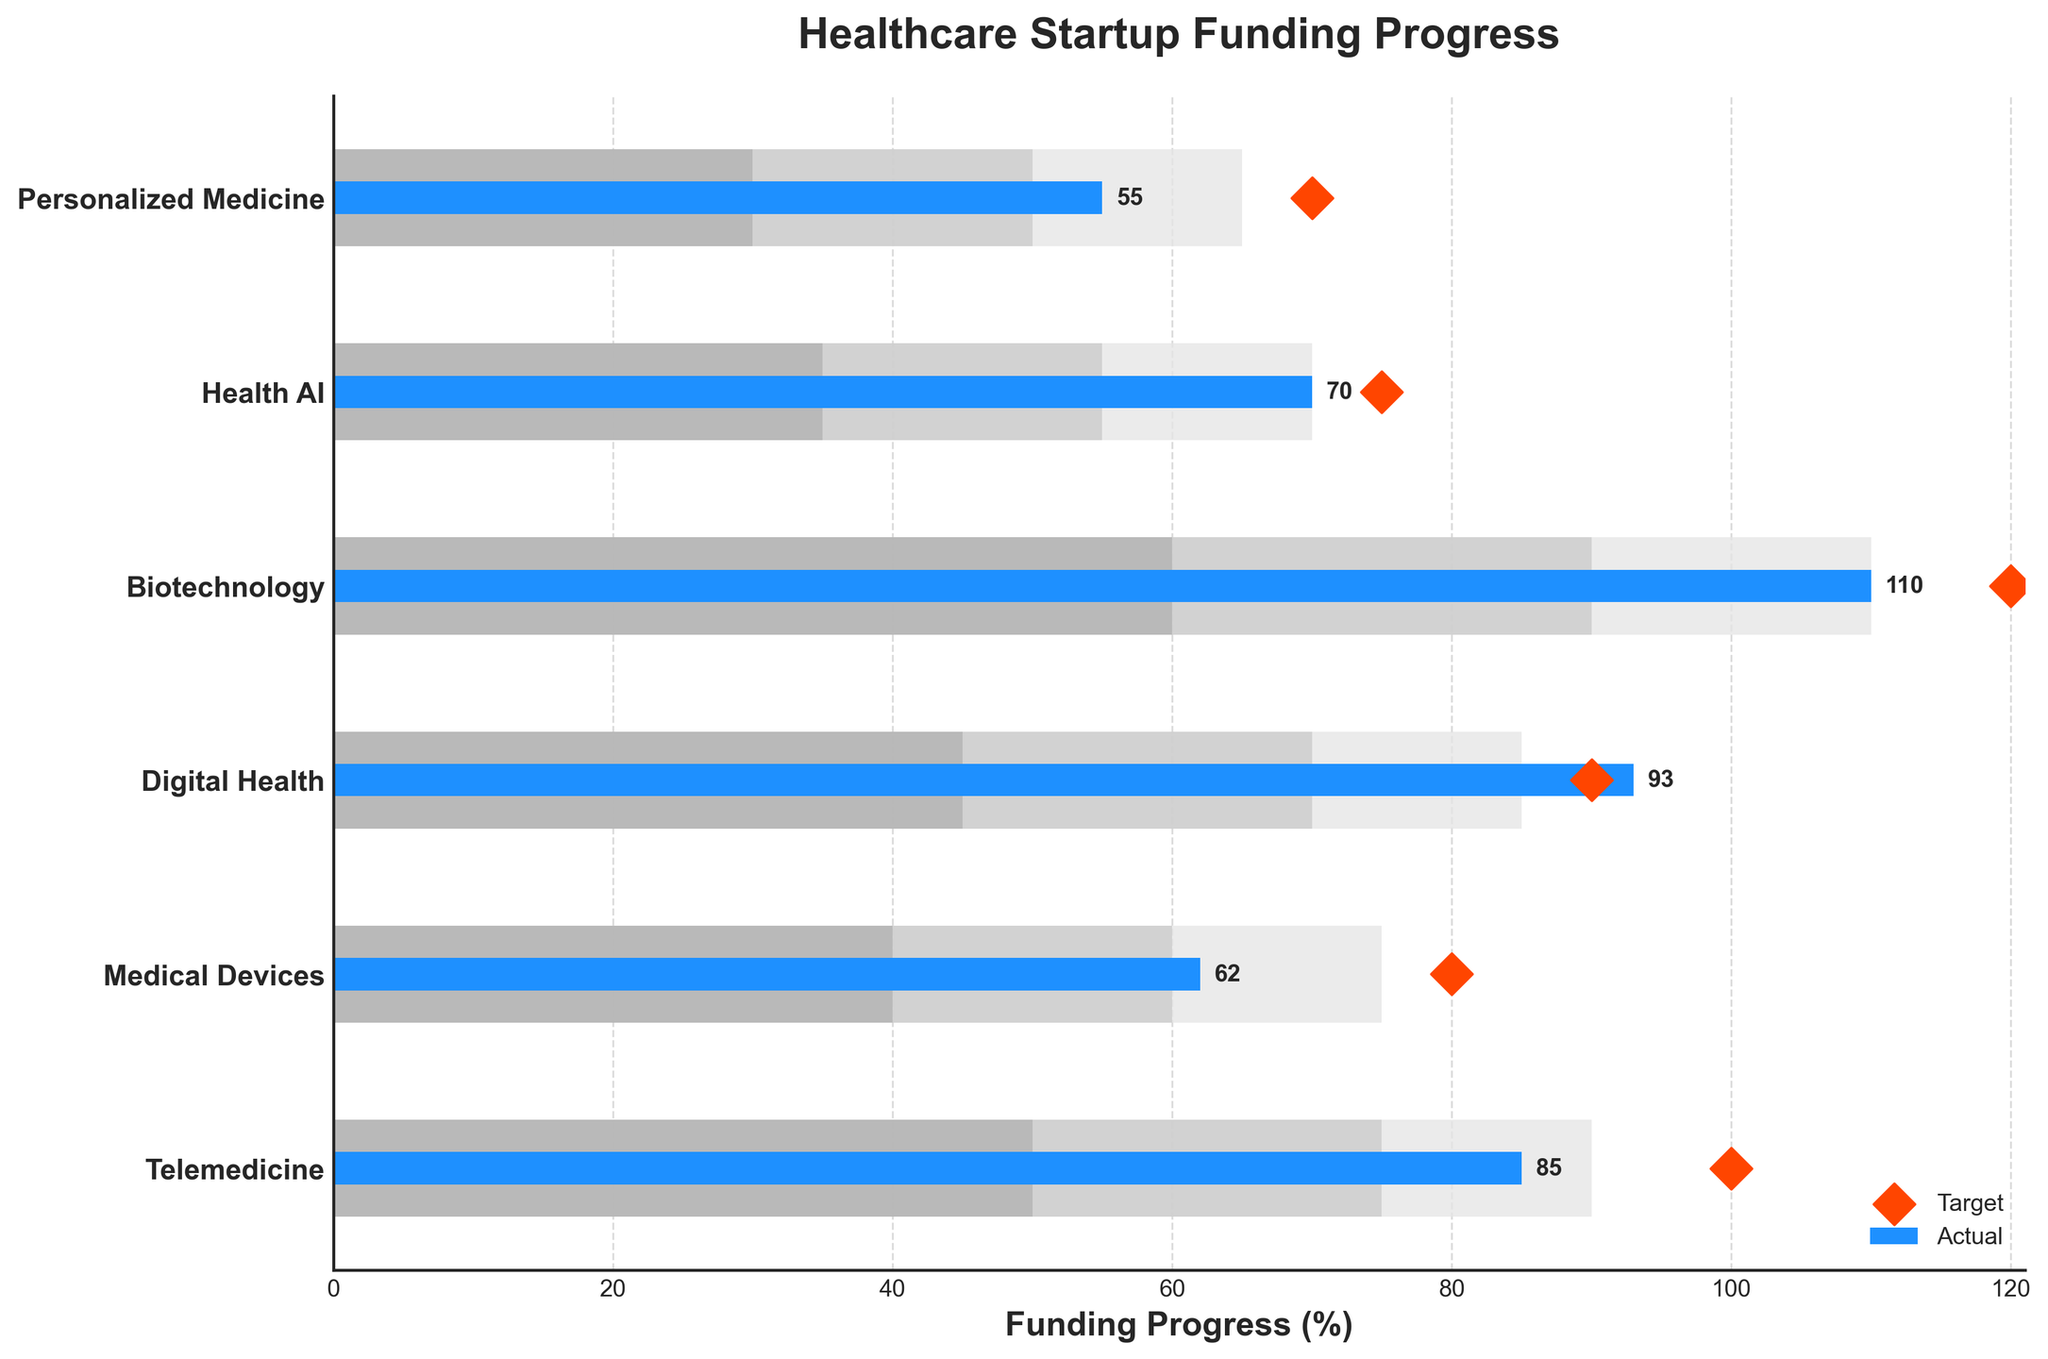What is the title of the figure? The title is written at the top of the plot. This usually gives an overview of what is being represented in the chart. In this case, the title is "Healthcare Startup Funding Progress."
Answer: Healthcare Startup Funding Progress Which category had the highest actual funding? By looking at the blue bars, we can identify the category with the longest blue bar. The Biotechnology category has the highest actual funding at 110%.
Answer: Biotechnology How many categories met or exceeded their funding targets? Compare the blue bars (actual funding) to the red diamonds (target markers). Digital Health and Biotechnology have their actual bars extending to or beyond the red diamond markers.
Answer: 2 Which category has the lowest funding target? By seeing where the red diamonds (target markers) are positioned, we can note that the Personalized Medicine category has the lowest target, marked at 70%.
Answer: Personalized Medicine What is the difference between the highest target and the lowest target? The highest target is for Biotechnology (120%) and the lowest target is for Personalized Medicine (70%). Subtract the lowest target from the highest target. 120 - 70 = 50.
Answer: 50 Which categories fall short of their targets? Identify where the blue bars (actual funding) fall short of the red diamonds (target markers). The categories falling short are Telemedicine, Medical Devices, Health AI, and Personalized Medicine.
Answer: Telemedicine, Medical Devices, Health AI, Personalized Medicine What is the average actual funding across all categories? Sum all the actual funding values: 85 (Telemedicine) + 62 (Medical Devices) + 93 (Digital Health) + 110 (Biotechnology) + 70 (Health AI) + 55 (Personalized Medicine) = 475. Divide by the number of categories, which is 6. 475 / 6 = 79.17
Answer: 79.17 Which category is closest to meeting its funding target without exceeding it? Compare the lengths of the blue bars to the positions of the red diamonds. The category closest to meeting its target without exceeding it is Health AI, with an actual funding of 70% and a target of 75%.
Answer: Health AI What is the median value of the target funding across all categories? The target values are: 70 (Personalized Medicine), 75 (Health AI), 80 (Medical Devices), 90 (Digital Health), 100 (Telemedicine), and 120 (Biotechnology). Arrange these values in ascending order: 70, 75, 80, 90, 100, 120. The median is the average of the middle two values, which are 80 and 90. (80 + 90) / 2 = 85.
Answer: 85 Which category's actual funding is exactly equal to its high range value? Look for the blue bar (actual) that ends exactly at the end of the lightest gray bar (high range value). The Health AI category's actual funding matches its high range value of 70%.
Answer: Health AI 